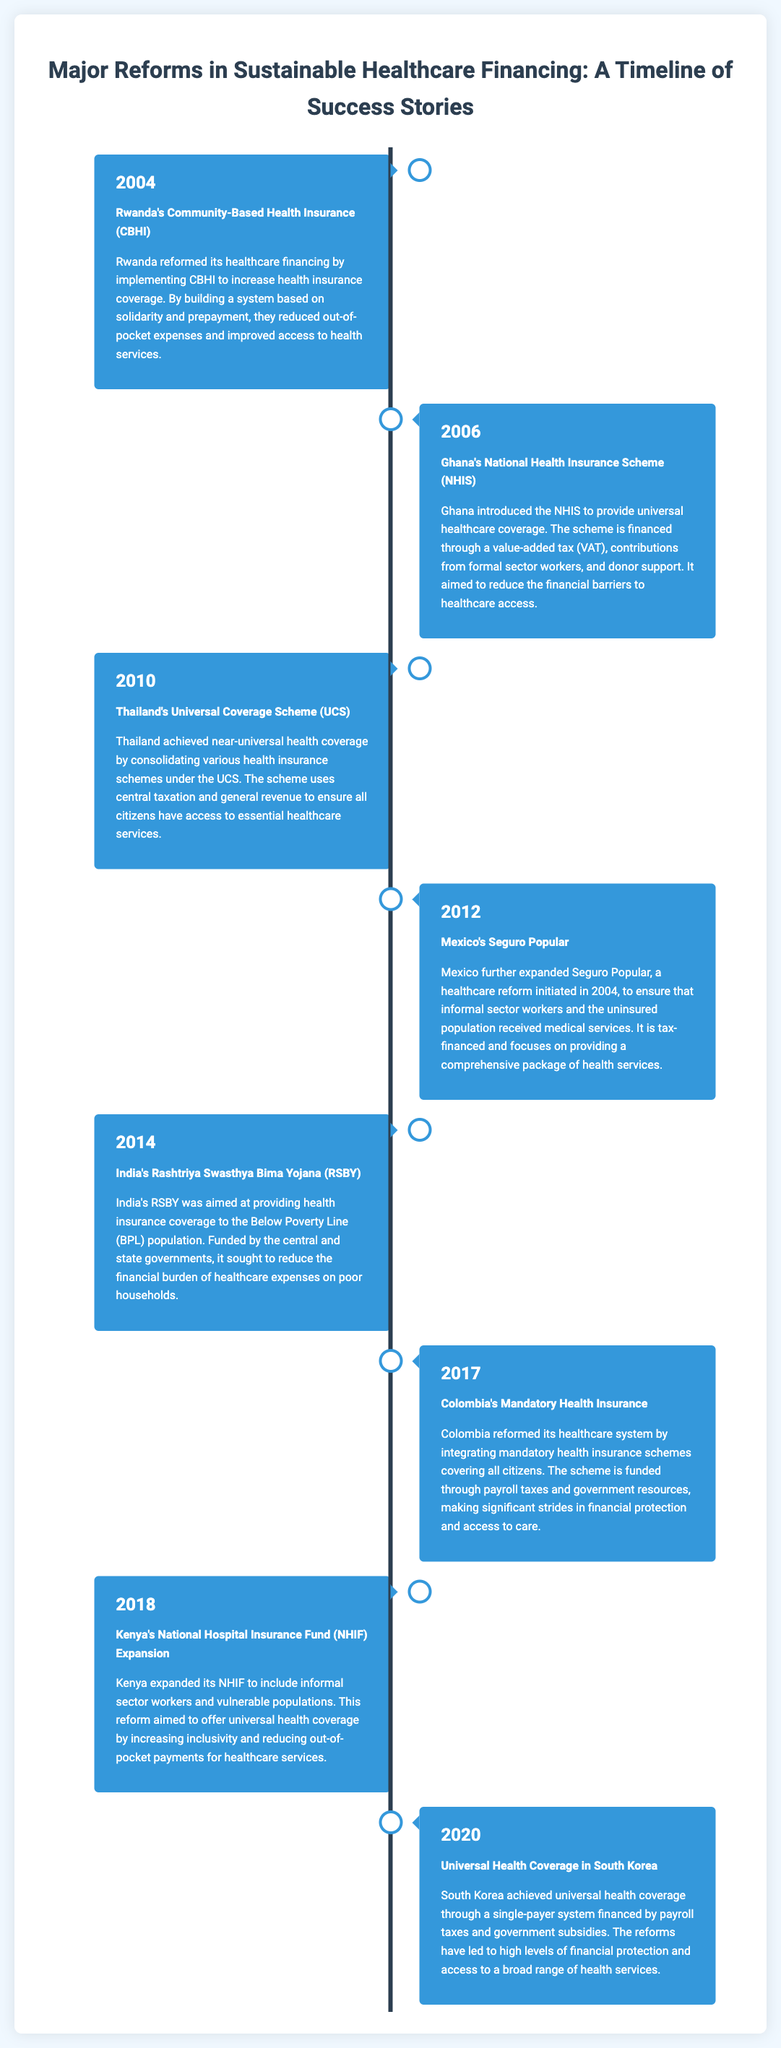what year was Rwanda's Community-Based Health Insurance implemented? The document states that Rwanda's Community-Based Health Insurance (CBHI) was reformed in 2004.
Answer: 2004 what is the financing source for Ghana's National Health Insurance Scheme? The document lists value-added tax, contributions from formal sector workers, and donor support as financing sources for Ghana's NHIS.
Answer: Value-added tax, contributions, donor support which country expanded its healthcare reform in 2012? The document mentions that Mexico expanded its Seguro Popular in 2012.
Answer: Mexico how did Thailand achieve near-universal health coverage? The document explains that Thailand consolidated various health insurance schemes under the Universal Coverage Scheme.
Answer: Consolidating health insurance schemes what was the main purpose of India’s Rashtriya Swasthya Bima Yojana? The document states that RSBY aimed at providing health insurance coverage to the Below Poverty Line population in India.
Answer: Providing health insurance to the BPL population which country implemented mandatory health insurance in 2017? The document notes that Colombia reformed its healthcare system to integrate mandatory health insurance schemes in 2017.
Answer: Colombia how did Kenya's NHIF reform aim to impact healthcare costs? The document indicates that the aim was to reduce out-of-pocket payments for healthcare services in Kenya.
Answer: Reduce out-of-pocket payments what type of healthcare coverage was achieved in South Korea in 2020? The document mentions that South Korea achieved universal health coverage through a single-payer system.
Answer: Universal health coverage what reform was initiated in Mexico in 2004? The document details that Seguro Popular was initiated in Mexico in 2004.
Answer: Seguro Popular 